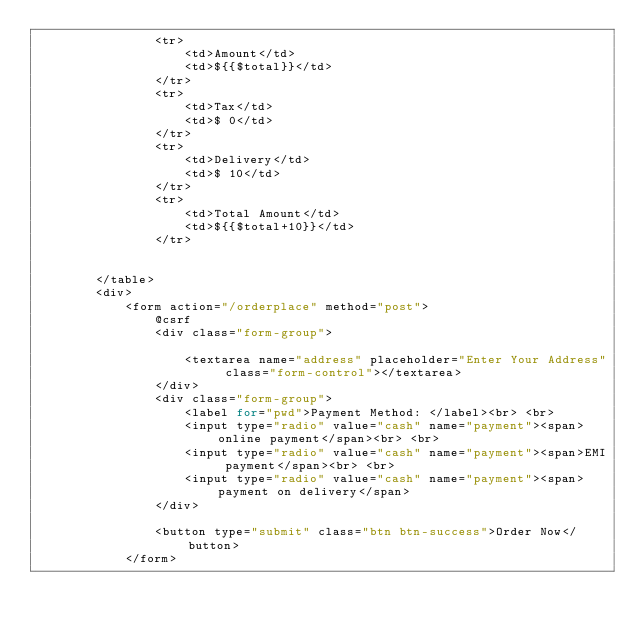Convert code to text. <code><loc_0><loc_0><loc_500><loc_500><_PHP_>                <tr>
                    <td>Amount</td>
                    <td>${{$total}}</td>
                </tr>
                <tr>
                    <td>Tax</td>
                    <td>$ 0</td>
                </tr>
                <tr>
                    <td>Delivery</td>
                    <td>$ 10</td>
                </tr>
                <tr>
                    <td>Total Amount</td>
                    <td>${{$total+10}}</td>
                </tr>


        </table>
        <div>
            <form action="/orderplace" method="post">
                @csrf
                <div class="form-group">

                    <textarea name="address" placeholder="Enter Your Address" class="form-control"></textarea>
                </div>
                <div class="form-group">
                    <label for="pwd">Payment Method: </label><br> <br>
                    <input type="radio" value="cash" name="payment"><span>online payment</span><br> <br>
                    <input type="radio" value="cash" name="payment"><span>EMI payment</span><br> <br>
                    <input type="radio" value="cash" name="payment"><span>payment on delivery</span>
                </div>

                <button type="submit" class="btn btn-success">Order Now</button>
            </form></code> 